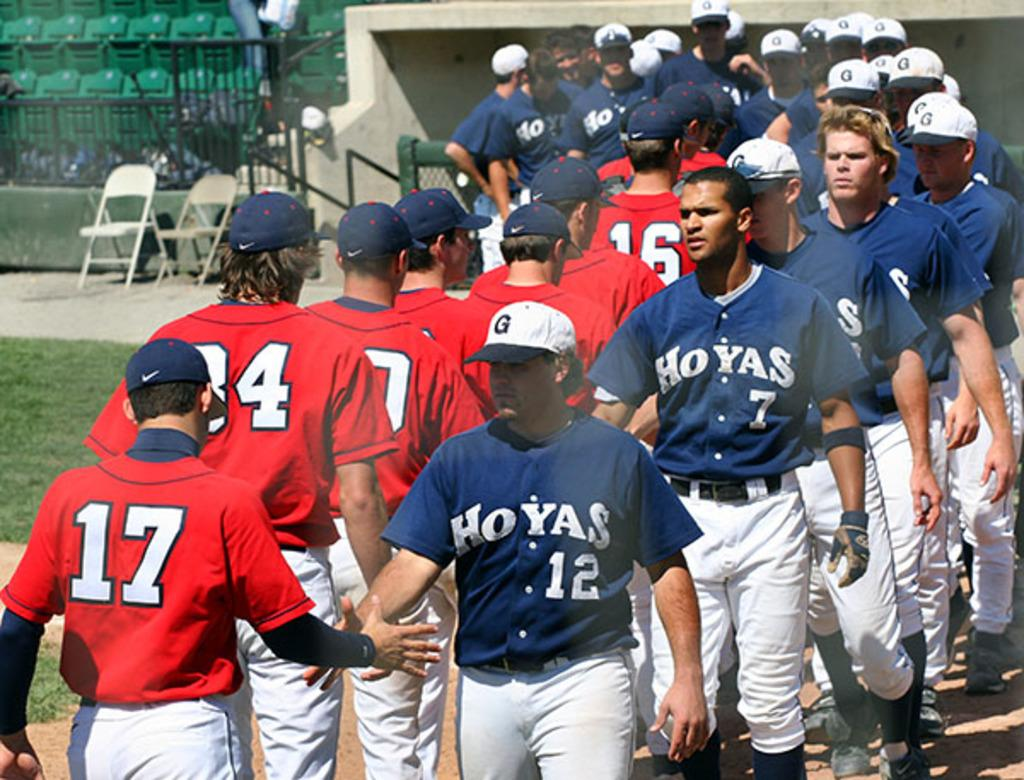<image>
Render a clear and concise summary of the photo. A line of sports players shake hands, the one at the back is in a number 17 shirt. 